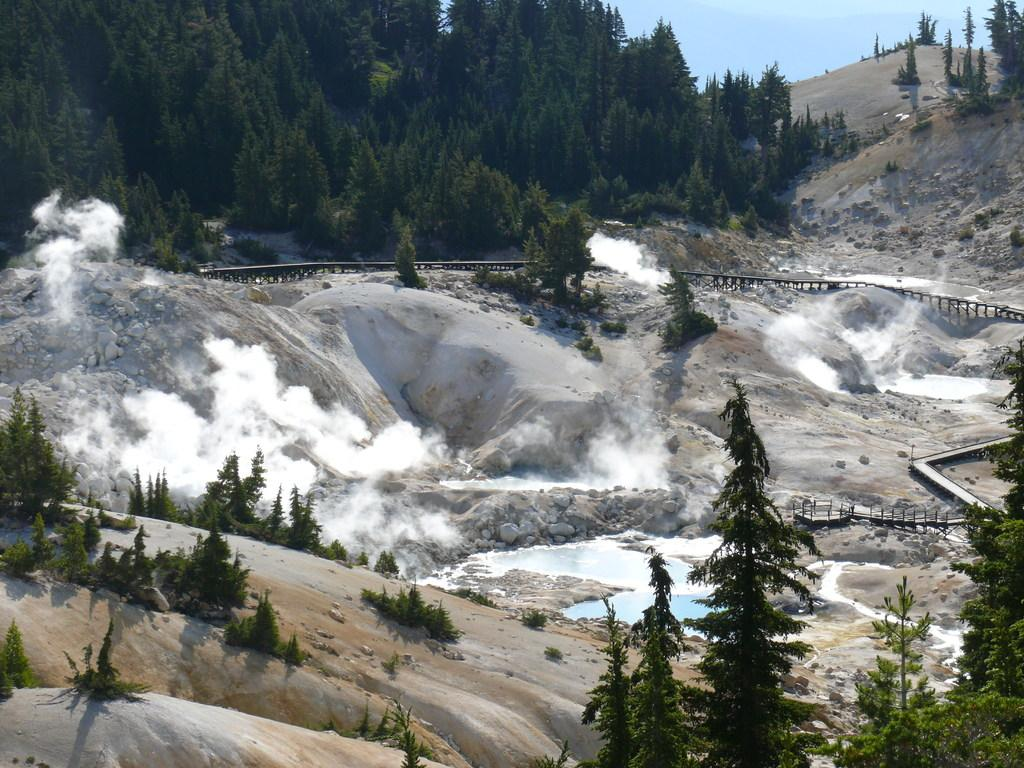What type of natural elements can be seen in the image? There are trees, stones, water, and hills visible in the image. What is the color of the smoke in the image? The smoke in the image is white. What is the color of the sky in the background of the image? The sky in the background of the image is blue. What type of cloth is being used for the operation in the image? There is no operation or cloth present in the image. How many times does the object in the image twist? There is no object that twists in the image. 